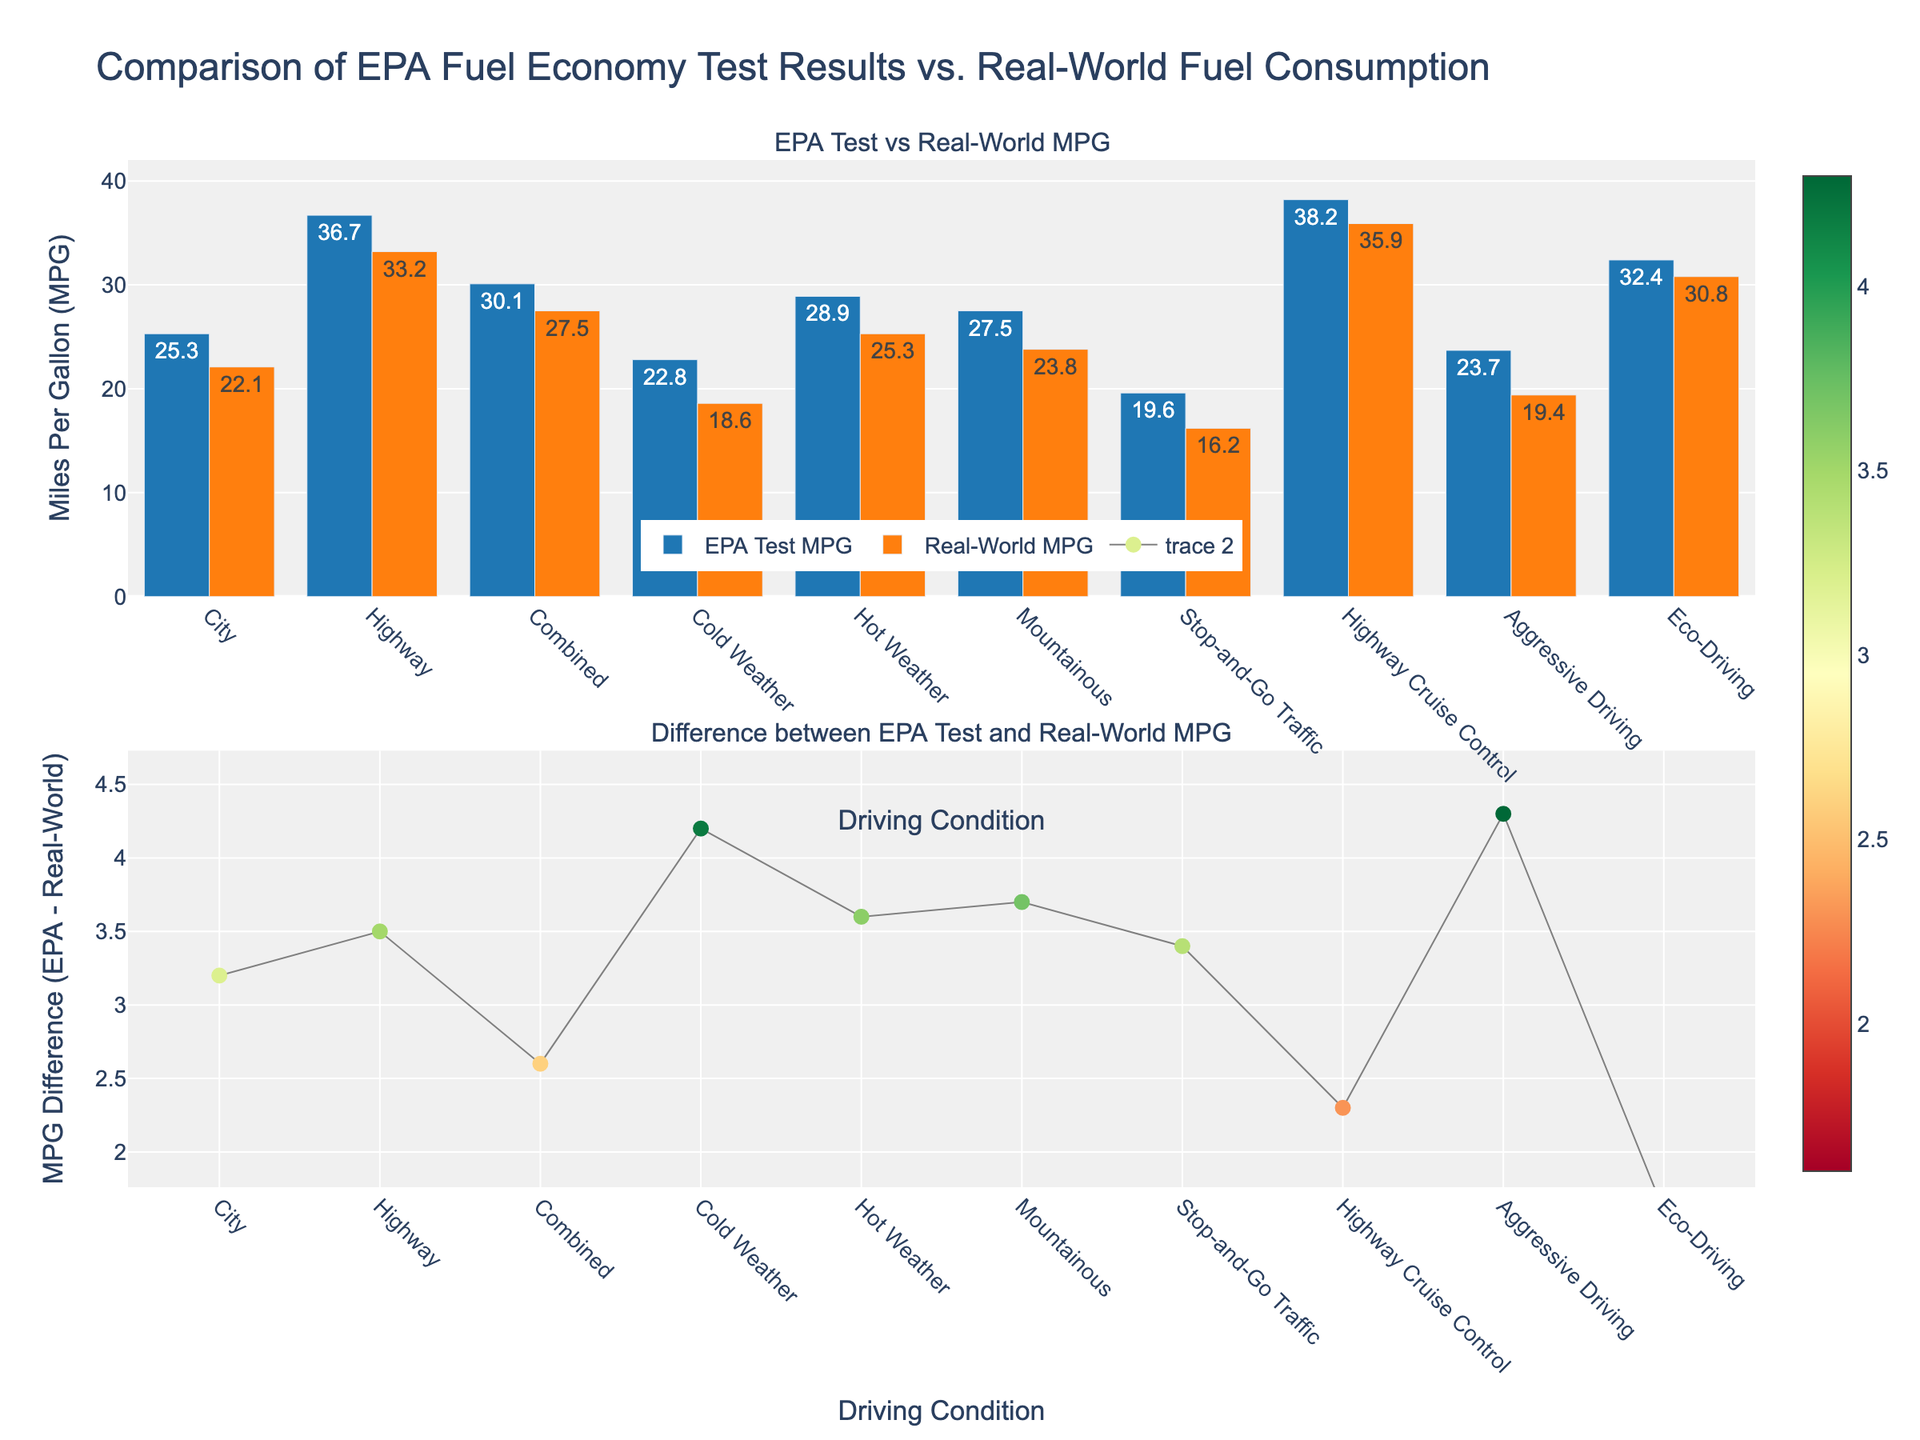What is the title of the figure? The title of the figure can be found at the top of the plot. It reads "Comparison of EPA Fuel Economy Test Results vs. Real-World Fuel Consumption".
Answer: Comparison of EPA Fuel Economy Test Results vs. Real-World Fuel Consumption Which driving condition has the highest EPA Test MPG? To determine this, look at the first subplot, which shows the bar chart for EPA Test MPG. The highest bar represents "Highway" at 36.7 MPG.
Answer: Highway What is the difference in MPG between the EPA Test and Real-World values for "Cold Weather"? The difference is represented in the second subplot, the value for "Cold Weather" can be found by calculating 22.8 - 18.6.
Answer: 4.2 MPG Which driving condition has the smallest difference between EPA Test MPG and Real-World MPG? Check the second subplot with the markers and lines. The smallest difference is for "Eco-Driving" with a difference of 1.6 MPG.
Answer: Eco-Driving List all the driving conditions where the Real-World MPG is greater than 30. Refer to the first subplot, look for the orange bars (Real-World MPG) exceeding the 30 MPG mark. Only one driving condition fits: "Highway".
Answer: Highway What is the average Real-World MPG for all listed driving conditions? Sum all the Real-World MPG values: 22.1 + 33.2 + 27.5 + 18.6 + 25.3 + 23.8 + 16.2 + 35.9 + 19.4 + 30.8 = 252.8. Divide by the number of conditions (10).
Answer: 25.28 MPG How does the difference between EPA Test MPG and Real-World MPG in "Highway Cruise Control" compare to "Stop-and-Go Traffic"? Look at the second subplot for both conditions, "Highway Cruise Control" has a smaller difference of 2.3 compared to 3.4 for "Stop-and-Go Traffic".
Answer: Smaller Which driving conditions have an MPG difference greater than 5? Refer to the second subplot and identify conditions with markers above 5 units. They are "Cold Weather" (4.2), "Hot Weather" (3.6), "Mountainous" (3.7), and "Aggressive Driving" (4.3).
Answer: None What is the combined average of the EPA Test MPG for "City" and "Highway"? The EPA Test MPG for "City" is 25.3 and for "Highway" is 36.7. Sum these values and divide by 2 for the average: (25.3 + 36.7) / 2 = 31.
Answer: 31 MPG 